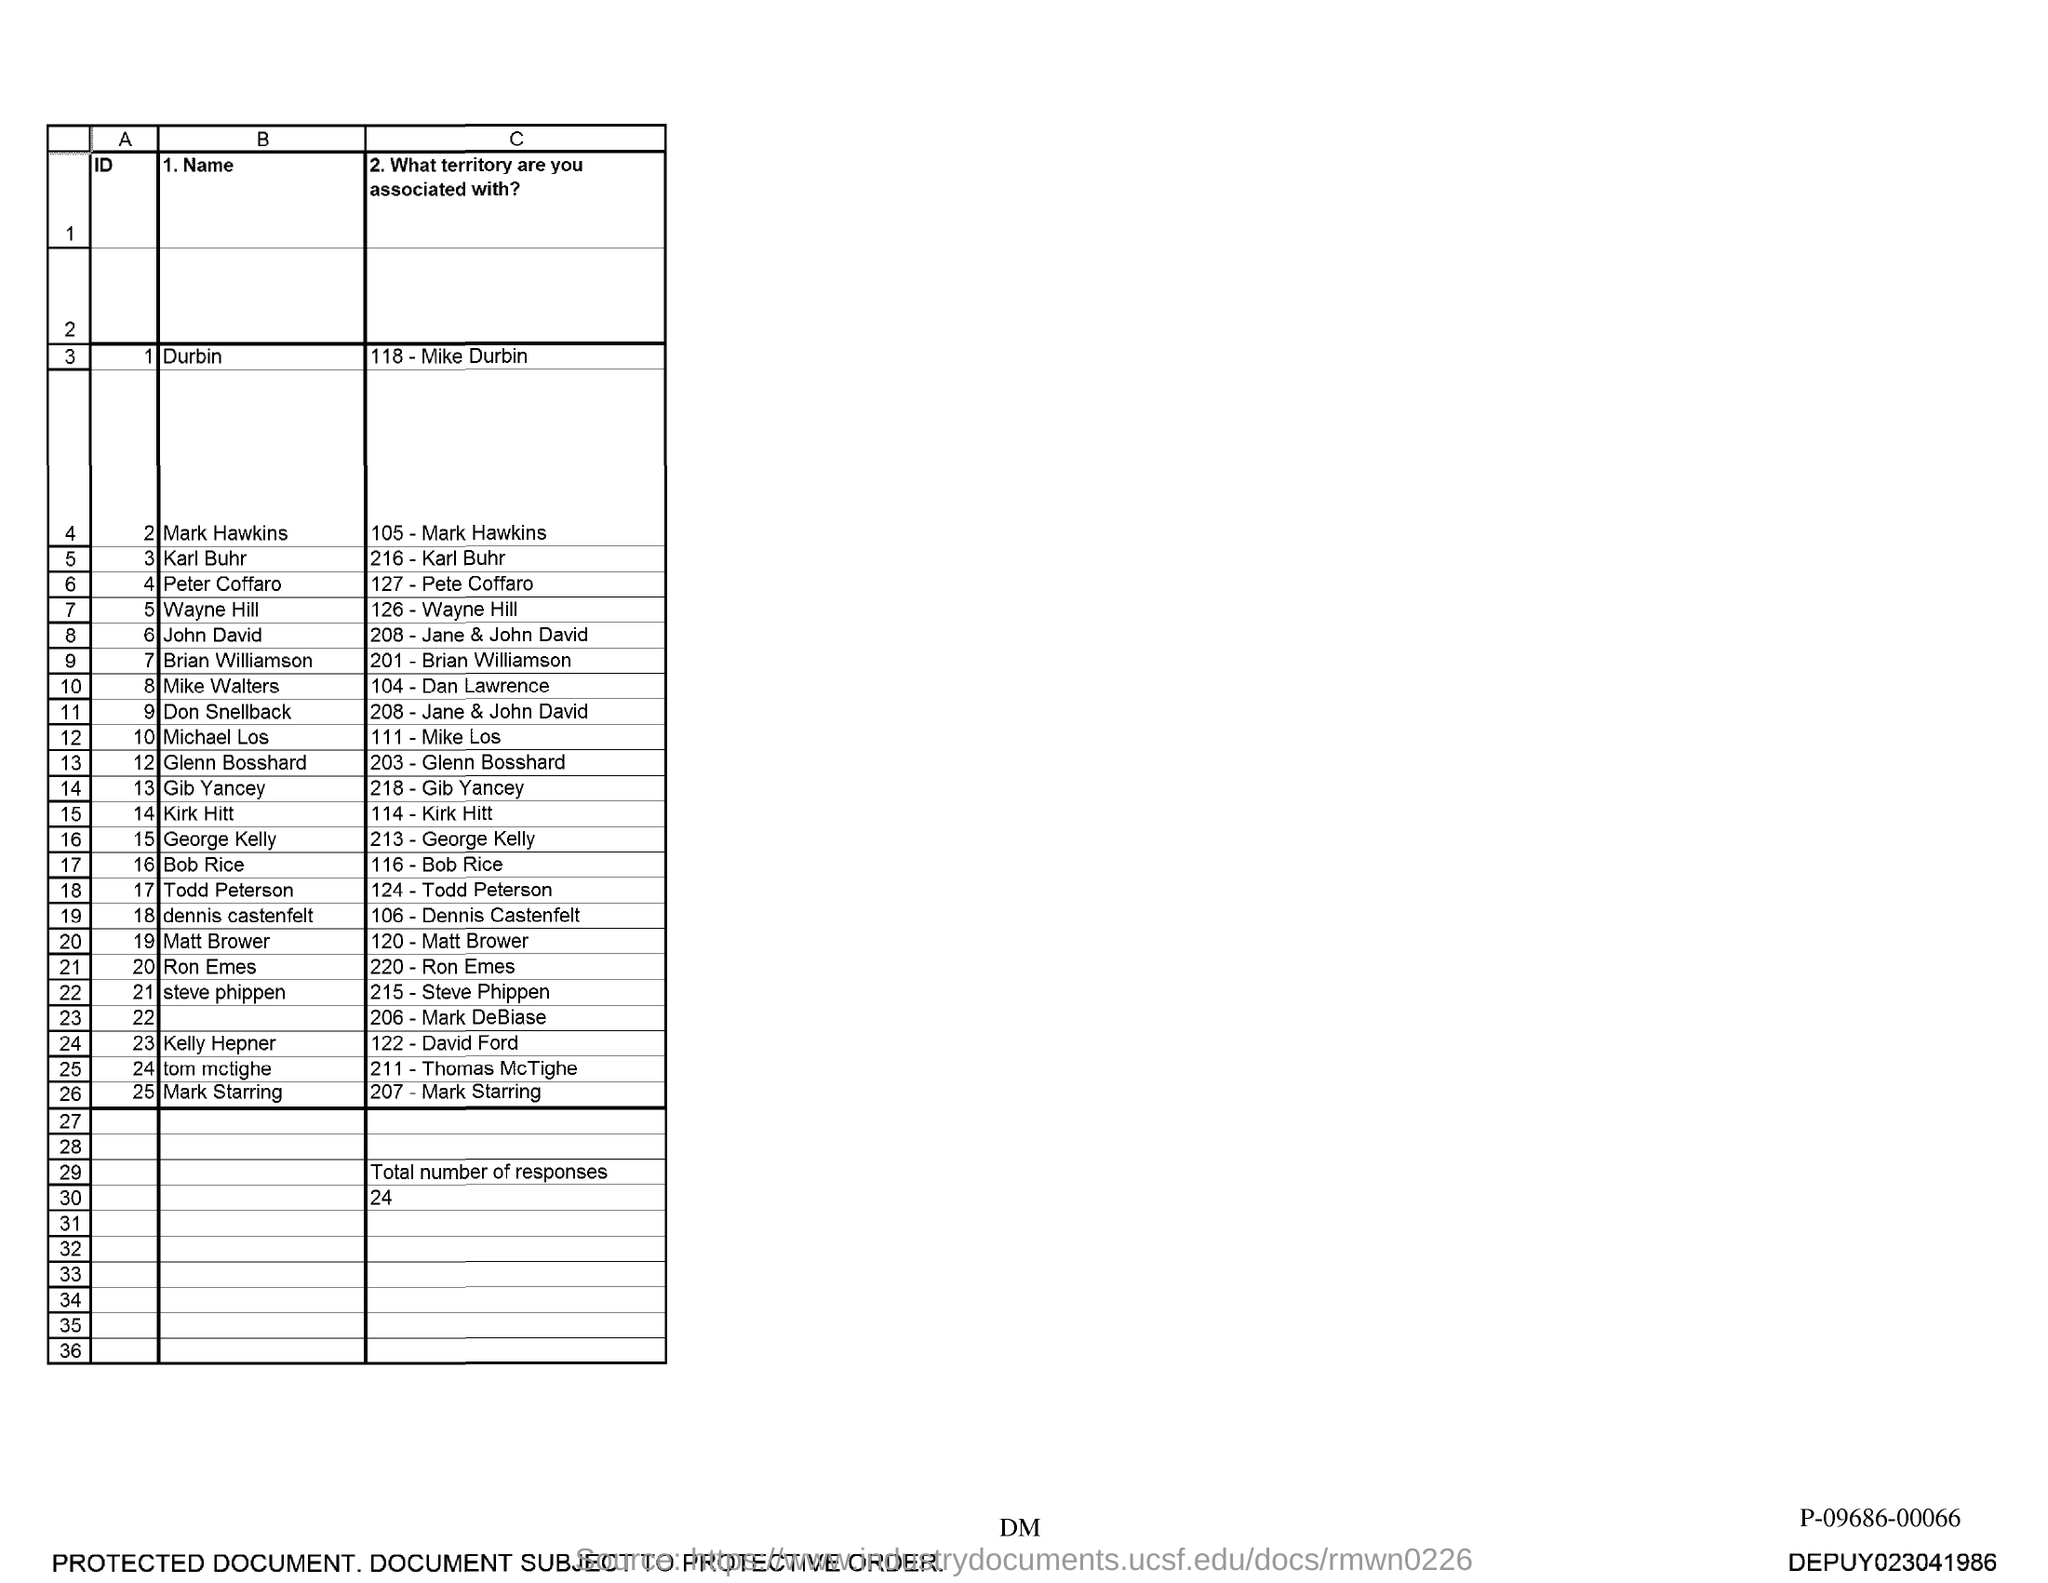Draw attention to some important aspects in this diagram. The total number of responses is 24. 